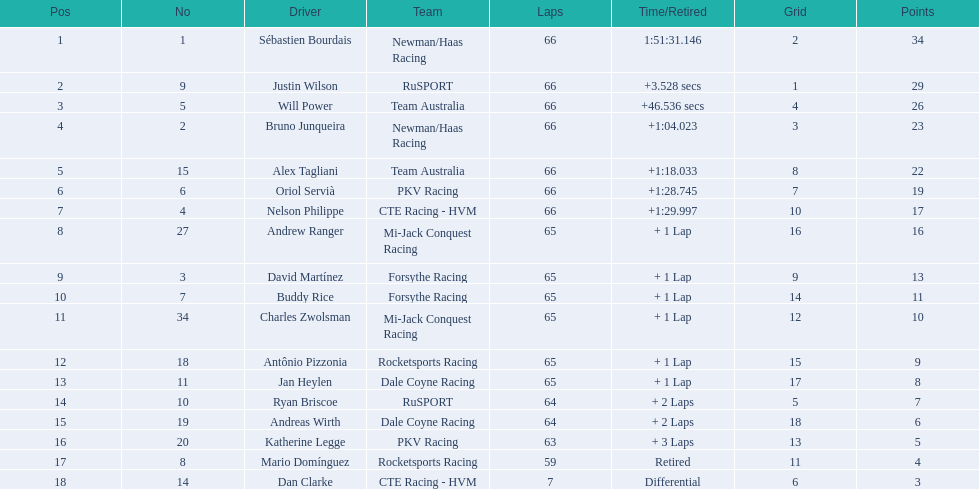Who are all the drivers? Sébastien Bourdais, Justin Wilson, Will Power, Bruno Junqueira, Alex Tagliani, Oriol Servià, Nelson Philippe, Andrew Ranger, David Martínez, Buddy Rice, Charles Zwolsman, Antônio Pizzonia, Jan Heylen, Ryan Briscoe, Andreas Wirth, Katherine Legge, Mario Domínguez, Dan Clarke. What position did they reach? 1, 2, 3, 4, 5, 6, 7, 8, 9, 10, 11, 12, 13, 14, 15, 16, 17, 18. What is the number for each driver? 1, 9, 5, 2, 15, 6, 4, 27, 3, 7, 34, 18, 11, 10, 19, 20, 8, 14. And which player's number and position match? Sébastien Bourdais. 